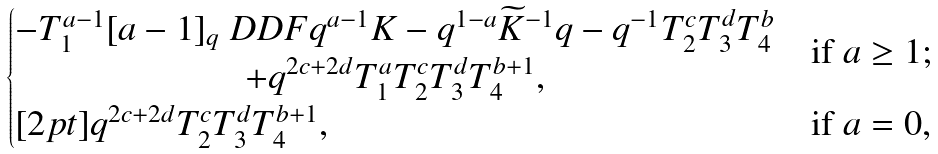Convert formula to latex. <formula><loc_0><loc_0><loc_500><loc_500>\begin{cases} \begin{matrix} - T _ { 1 } ^ { a - 1 } [ a - 1 ] _ { q } \ D D F { q ^ { a - 1 } K - q ^ { 1 - a } \widetilde { K } ^ { - 1 } } { q - q ^ { - 1 } } T _ { 2 } ^ { c } T _ { 3 } ^ { d } T _ { 4 } ^ { b } \\ + q ^ { 2 c + 2 d } T _ { 1 } ^ { a } T _ { 2 } ^ { c } T _ { 3 } ^ { d } T _ { 4 } ^ { b + 1 } , \end{matrix} & \text {if $a\geq 1$;} \\ [ 2 p t ] q ^ { 2 c + 2 d } T _ { 2 } ^ { c } T _ { 3 } ^ { d } T _ { 4 } ^ { b + 1 } , & \text {if $a=0$,} \end{cases}</formula> 